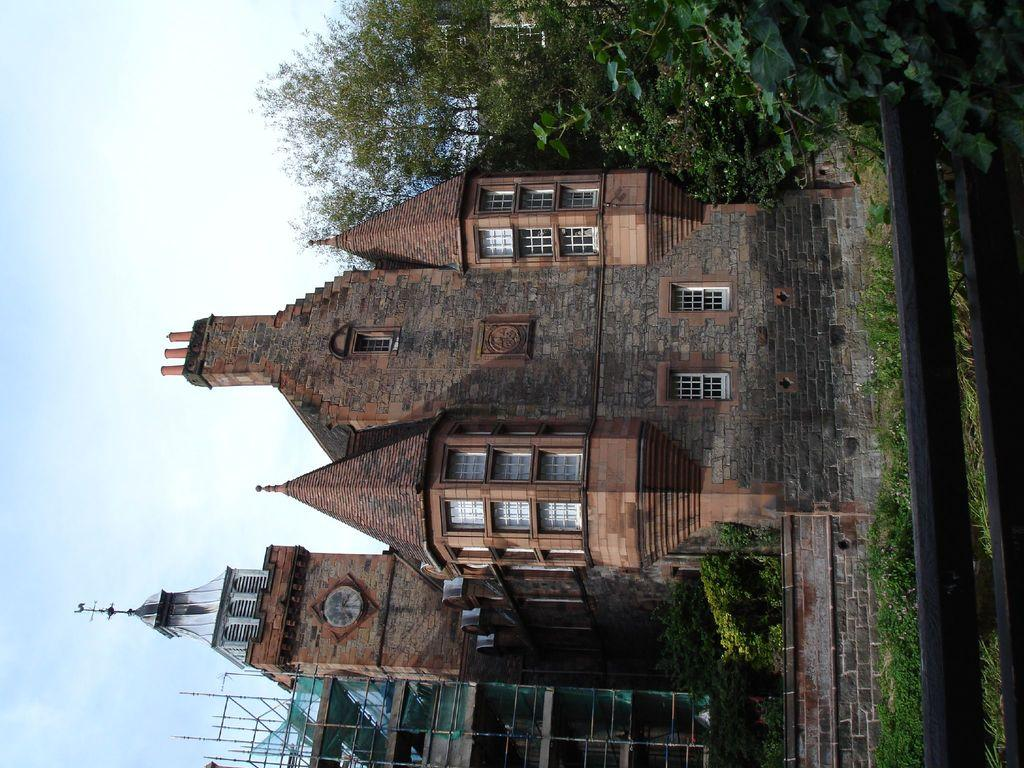What type of structure is visible in the image? There is a building in the image. What other elements can be seen in the image besides the building? There are trees in the image. Can you describe any specific features of the building? There is a clock on the building. How many rabbits can be seen sleeping on the fork in the image? There are no rabbits or forks present in the image. 